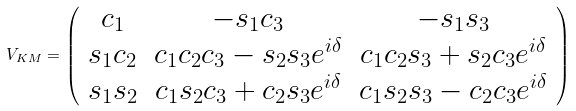<formula> <loc_0><loc_0><loc_500><loc_500>V _ { K M } = \left ( \begin{array} { c c c } c _ { 1 } & - s _ { 1 } c _ { 3 } & - s _ { 1 } s _ { 3 } \\ s _ { 1 } c _ { 2 } & c _ { 1 } c _ { 2 } c _ { 3 } - s _ { 2 } s _ { 3 } e ^ { i \delta } & c _ { 1 } c _ { 2 } s _ { 3 } + s _ { 2 } c _ { 3 } e ^ { i \delta } \\ s _ { 1 } s _ { 2 } & c _ { 1 } s _ { 2 } c _ { 3 } + c _ { 2 } s _ { 3 } e ^ { i \delta } & c _ { 1 } s _ { 2 } s _ { 3 } - c _ { 2 } c _ { 3 } e ^ { i \delta } \end{array} \right )</formula> 